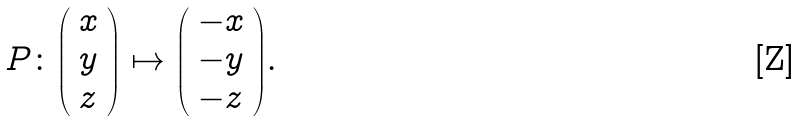Convert formula to latex. <formula><loc_0><loc_0><loc_500><loc_500>P \colon { \left ( \begin{array} { l } { x } \\ { y } \\ { z } \end{array} \right ) } \mapsto { \left ( \begin{array} { l } { - x } \\ { - y } \\ { - z } \end{array} \right ) } .</formula> 